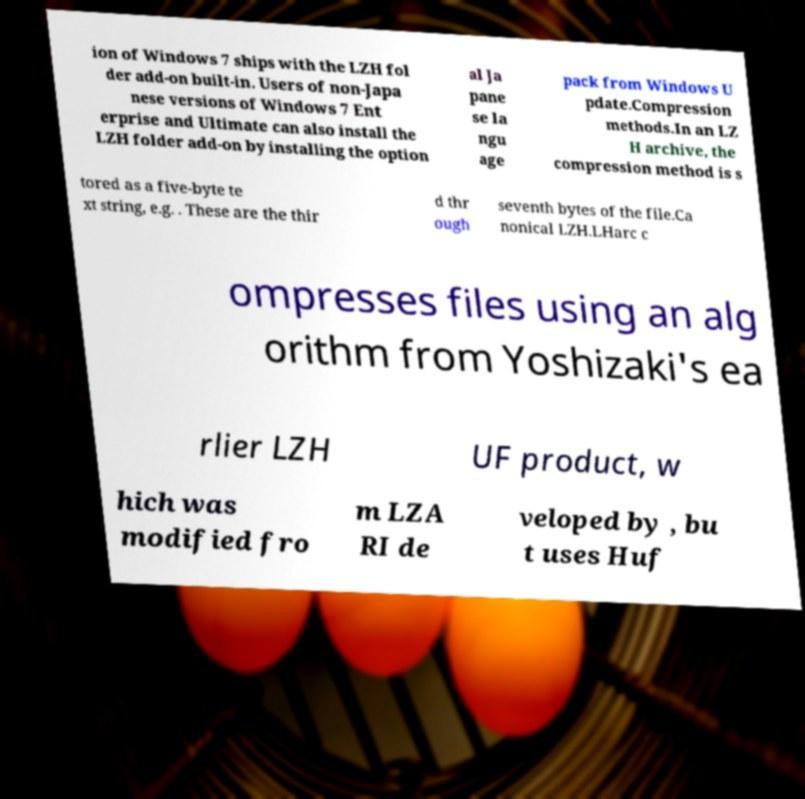Could you extract and type out the text from this image? ion of Windows 7 ships with the LZH fol der add-on built-in. Users of non-Japa nese versions of Windows 7 Ent erprise and Ultimate can also install the LZH folder add-on by installing the option al Ja pane se la ngu age pack from Windows U pdate.Compression methods.In an LZ H archive, the compression method is s tored as a five-byte te xt string, e.g. . These are the thir d thr ough seventh bytes of the file.Ca nonical LZH.LHarc c ompresses files using an alg orithm from Yoshizaki's ea rlier LZH UF product, w hich was modified fro m LZA RI de veloped by , bu t uses Huf 